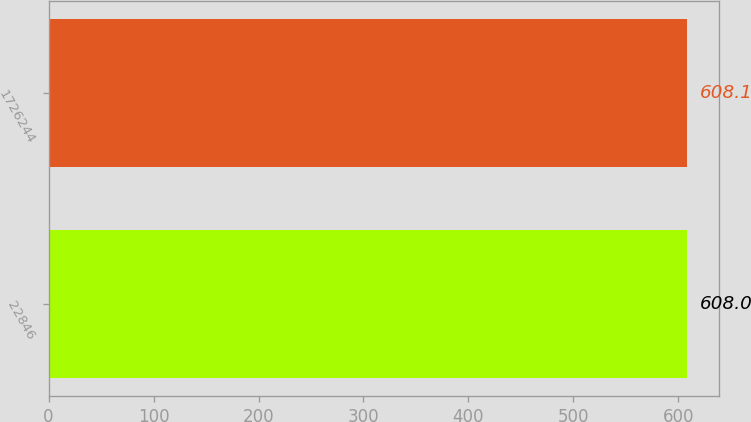<chart> <loc_0><loc_0><loc_500><loc_500><bar_chart><fcel>22846<fcel>1726244<nl><fcel>608<fcel>608.1<nl></chart> 